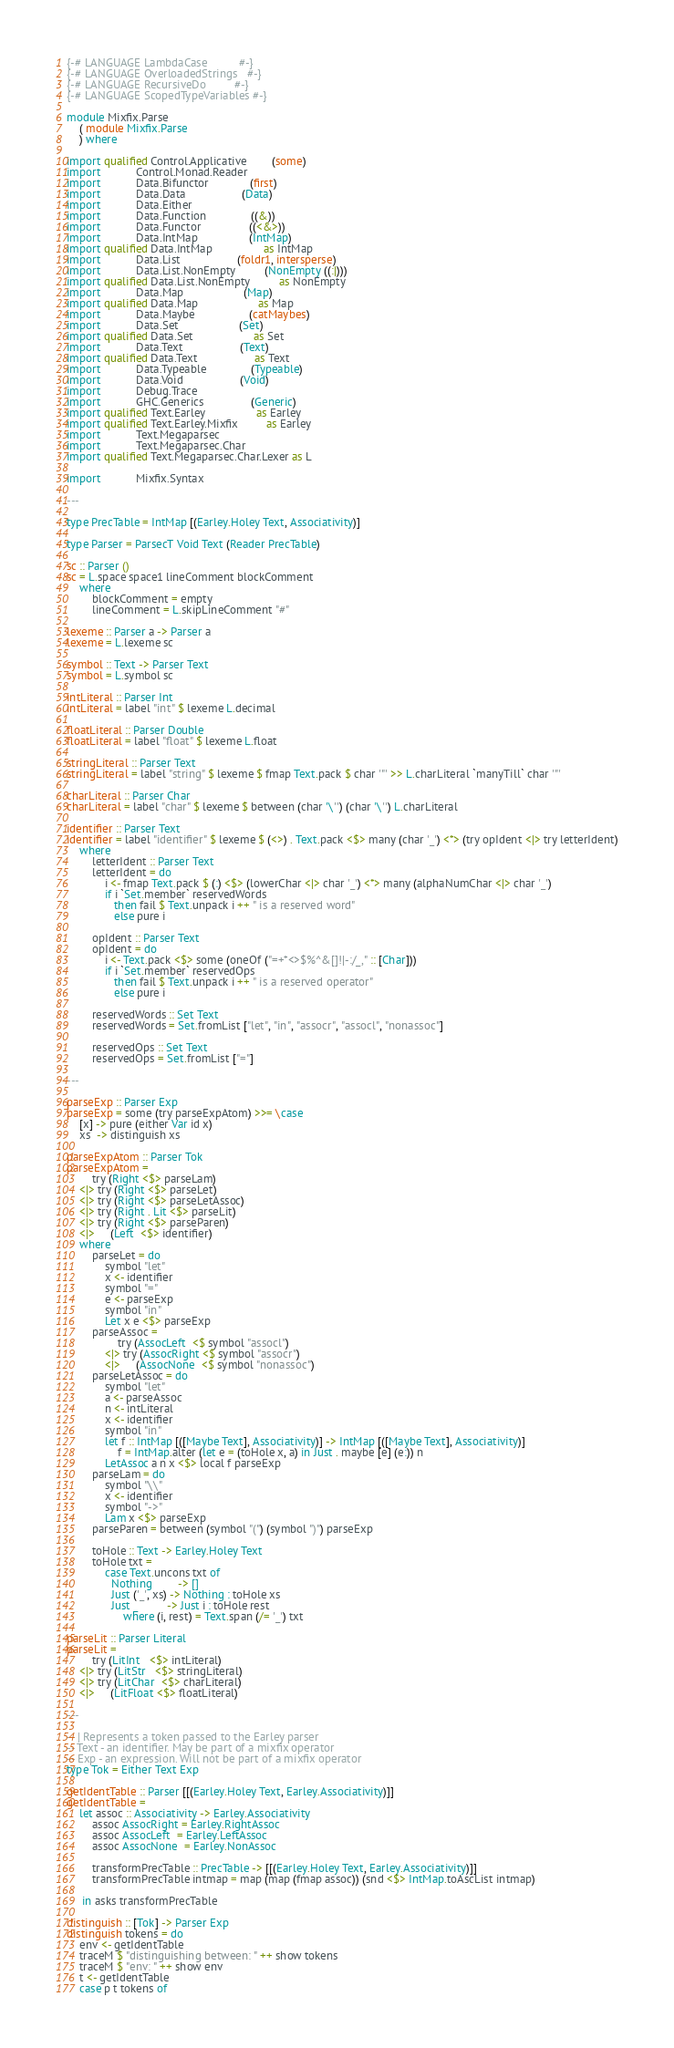<code> <loc_0><loc_0><loc_500><loc_500><_Haskell_>{-# LANGUAGE LambdaCase          #-}
{-# LANGUAGE OverloadedStrings   #-}
{-# LANGUAGE RecursiveDo         #-}
{-# LANGUAGE ScopedTypeVariables #-}

module Mixfix.Parse
    ( module Mixfix.Parse
    ) where

import qualified Control.Applicative        (some)
import           Control.Monad.Reader
import           Data.Bifunctor             (first)
import           Data.Data                  (Data)
import           Data.Either
import           Data.Function              ((&))
import           Data.Functor               ((<&>))
import           Data.IntMap                (IntMap)
import qualified Data.IntMap                as IntMap
import           Data.List                  (foldr1, intersperse)
import           Data.List.NonEmpty         (NonEmpty ((:|)))
import qualified Data.List.NonEmpty         as NonEmpty
import           Data.Map                   (Map)
import qualified Data.Map                   as Map
import           Data.Maybe                 (catMaybes)
import           Data.Set                   (Set)
import qualified Data.Set                   as Set
import           Data.Text                  (Text)
import qualified Data.Text                  as Text
import           Data.Typeable              (Typeable)
import           Data.Void                  (Void)
import           Debug.Trace
import           GHC.Generics               (Generic)
import qualified Text.Earley                as Earley
import qualified Text.Earley.Mixfix         as Earley
import           Text.Megaparsec
import           Text.Megaparsec.Char
import qualified Text.Megaparsec.Char.Lexer as L

import           Mixfix.Syntax

---

type PrecTable = IntMap [(Earley.Holey Text, Associativity)]

type Parser = ParsecT Void Text (Reader PrecTable)

sc :: Parser ()
sc = L.space space1 lineComment blockComment
    where
        blockComment = empty
        lineComment = L.skipLineComment "#"

lexeme :: Parser a -> Parser a
lexeme = L.lexeme sc

symbol :: Text -> Parser Text
symbol = L.symbol sc

intLiteral :: Parser Int
intLiteral = label "int" $ lexeme L.decimal

floatLiteral :: Parser Double
floatLiteral = label "float" $ lexeme L.float

stringLiteral :: Parser Text
stringLiteral = label "string" $ lexeme $ fmap Text.pack $ char '"' >> L.charLiteral `manyTill` char '"'

charLiteral :: Parser Char
charLiteral = label "char" $ lexeme $ between (char '\'') (char '\'') L.charLiteral

identifier :: Parser Text
identifier = label "identifier" $ lexeme $ (<>) . Text.pack <$> many (char '_') <*> (try opIdent <|> try letterIdent)
    where
        letterIdent :: Parser Text
        letterIdent = do
            i <- fmap Text.pack $ (:) <$> (lowerChar <|> char '_') <*> many (alphaNumChar <|> char '_')
            if i `Set.member` reservedWords
               then fail $ Text.unpack i ++ " is a reserved word"
               else pure i

        opIdent :: Parser Text
        opIdent = do
            i <- Text.pack <$> some (oneOf ("=+*<>$%^&[]!|-:/_," :: [Char]))
            if i `Set.member` reservedOps
               then fail $ Text.unpack i ++ " is a reserved operator"
               else pure i

        reservedWords :: Set Text
        reservedWords = Set.fromList ["let", "in", "assocr", "assocl", "nonassoc"]

        reservedOps :: Set Text
        reservedOps = Set.fromList ["="]

---

parseExp :: Parser Exp
parseExp = some (try parseExpAtom) >>= \case
    [x] -> pure (either Var id x)
    xs  -> distinguish xs

parseExpAtom :: Parser Tok
parseExpAtom =
        try (Right <$> parseLam)
    <|> try (Right <$> parseLet)
    <|> try (Right <$> parseLetAssoc)
    <|> try (Right . Lit <$> parseLit)
    <|> try (Right <$> parseParen)
    <|>     (Left  <$> identifier)
    where
        parseLet = do
            symbol "let"
            x <- identifier
            symbol "="
            e <- parseExp
            symbol "in"
            Let x e <$> parseExp
        parseAssoc =
                try (AssocLeft  <$ symbol "assocl")
            <|> try (AssocRight <$ symbol "assocr")
            <|>     (AssocNone  <$ symbol "nonassoc")
        parseLetAssoc = do
            symbol "let"
            a <- parseAssoc
            n <- intLiteral
            x <- identifier
            symbol "in"
            let f :: IntMap [([Maybe Text], Associativity)] -> IntMap [([Maybe Text], Associativity)]
                f = IntMap.alter (let e = (toHole x, a) in Just . maybe [e] (e:)) n
            LetAssoc a n x <$> local f parseExp
        parseLam = do
            symbol "\\"
            x <- identifier
            symbol "->"
            Lam x <$> parseExp
        parseParen = between (symbol "(") (symbol ")") parseExp

        toHole :: Text -> Earley.Holey Text
        toHole txt =
            case Text.uncons txt of
              Nothing        -> []
              Just ('_', xs) -> Nothing : toHole xs
              Just _         -> Just i : toHole rest
                  where (i, rest) = Text.span (/= '_') txt

parseLit :: Parser Literal
parseLit =
        try (LitInt   <$> intLiteral)
    <|> try (LitStr   <$> stringLiteral)
    <|> try (LitChar  <$> charLiteral)
    <|>     (LitFloat <$> floatLiteral)

---

-- | Represents a token passed to the Earley parser
-- Text - an identifier. May be part of a mixfix operator
-- Exp - an expression. Will not be part of a mixfix operator
type Tok = Either Text Exp

getIdentTable :: Parser [[(Earley.Holey Text, Earley.Associativity)]]
getIdentTable =
    let assoc :: Associativity -> Earley.Associativity
        assoc AssocRight = Earley.RightAssoc
        assoc AssocLeft  = Earley.LeftAssoc
        assoc AssocNone  = Earley.NonAssoc

        transformPrecTable :: PrecTable -> [[(Earley.Holey Text, Earley.Associativity)]]
        transformPrecTable intmap = map (map (fmap assoc)) (snd <$> IntMap.toAscList intmap)

     in asks transformPrecTable

distinguish :: [Tok] -> Parser Exp
distinguish tokens = do
    env <- getIdentTable
    traceM $ "distinguishing between: " ++ show tokens
    traceM $ "env: " ++ show env
    t <- getIdentTable
    case p t tokens of</code> 